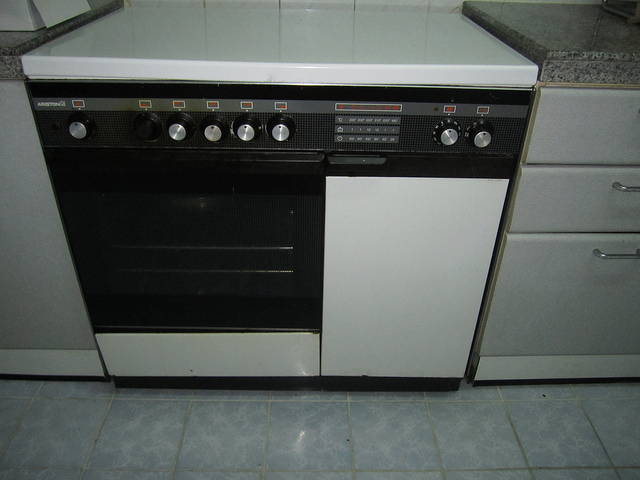<image>Does this appliance have a range top? It's ambiguous whether the appliance has a range top. Does this appliance have a range top? It is not sure if this appliance has a range top. It can be both yes or no. 